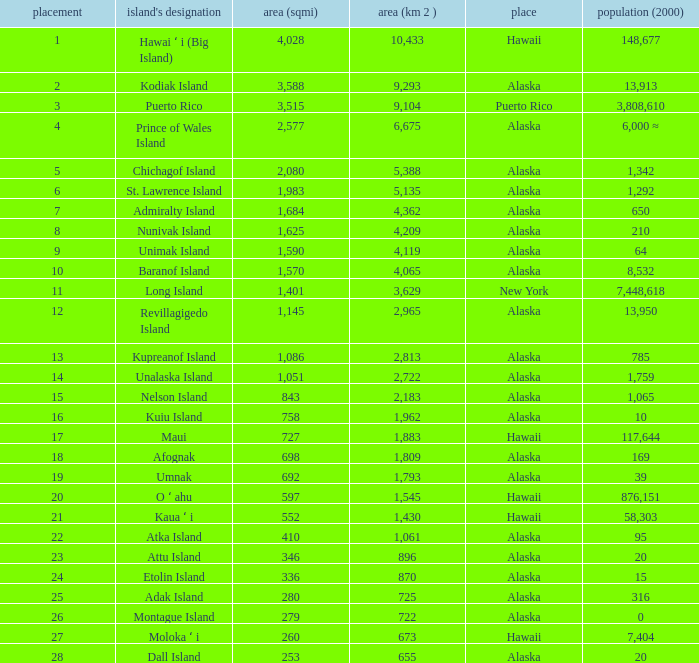What is the highest rank for Nelson Island with area more than 2,183? None. 